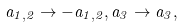Convert formula to latex. <formula><loc_0><loc_0><loc_500><loc_500>a _ { 1 , 2 } \to - a _ { 1 , 2 } , a _ { 3 } \to a _ { 3 } ,</formula> 